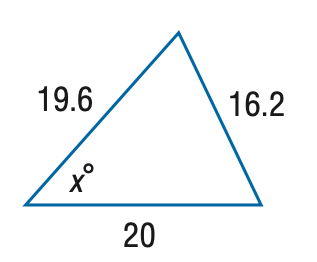Answer the mathemtical geometry problem and directly provide the correct option letter.
Question: Find x. Round the angle measure to the nearest degree.
Choices: A: 43 B: 48 C: 53 D: 58 B 